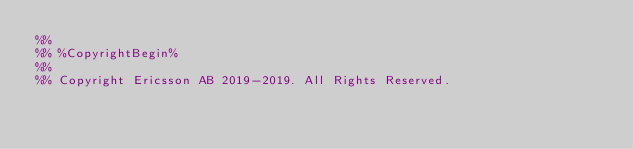<code> <loc_0><loc_0><loc_500><loc_500><_Erlang_>%%
%% %CopyrightBegin%
%%
%% Copyright Ericsson AB 2019-2019. All Rights Reserved.</code> 